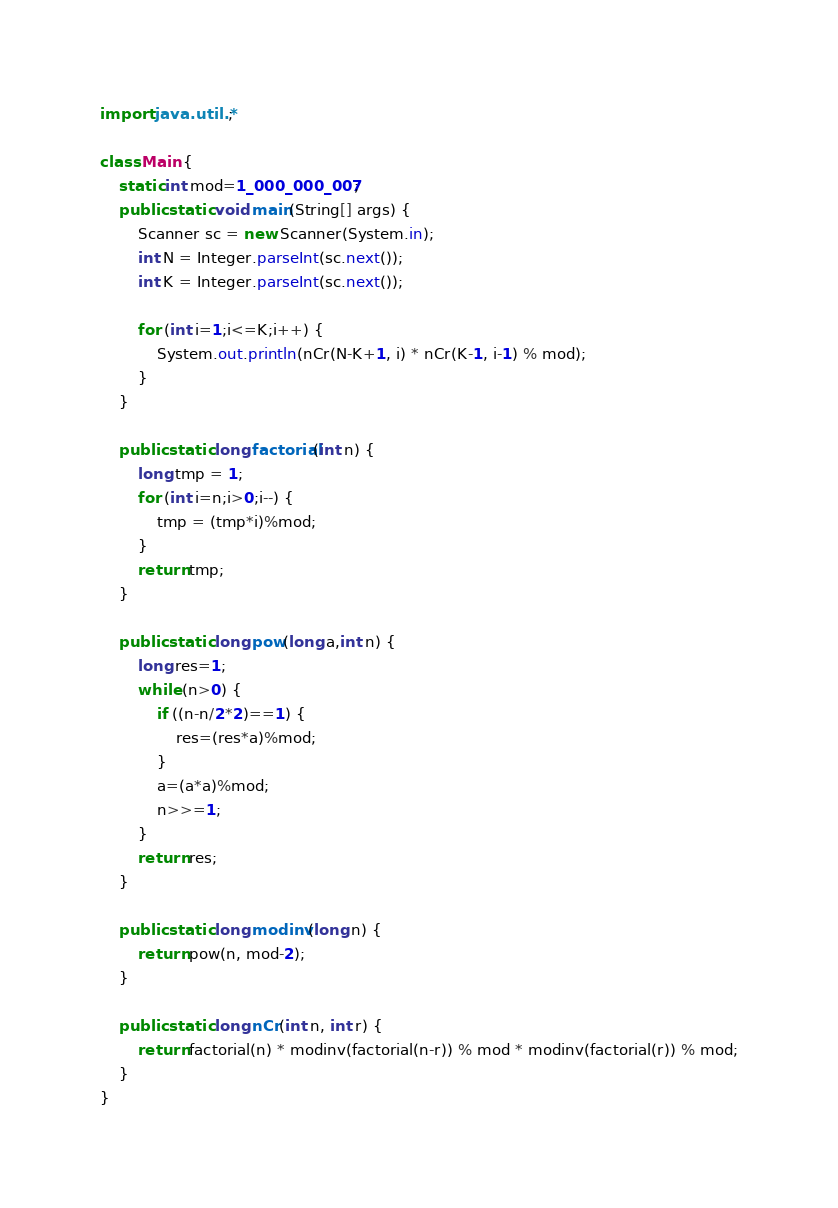<code> <loc_0><loc_0><loc_500><loc_500><_Java_>import java.util.*;

class Main {
	static int mod=1_000_000_007;
	public static void main(String[] args) {
		Scanner sc = new Scanner(System.in);
		int N = Integer.parseInt(sc.next());
		int K = Integer.parseInt(sc.next());

		for (int i=1;i<=K;i++) {
			System.out.println(nCr(N-K+1, i) * nCr(K-1, i-1) % mod);
		}
	}

	public static long factorial(int n) {
		long tmp = 1;
		for (int i=n;i>0;i--) {
			tmp = (tmp*i)%mod;
		}
		return tmp;
	}

	public static long pow(long a,int n) {
	    long res=1;
	    while (n>0) {
	        if ((n-n/2*2)==1) {
	            res=(res*a)%mod;
	        }
	        a=(a*a)%mod;
	        n>>=1;
	    }
	    return res;
	}

	public static long modinv(long n) {
		return pow(n, mod-2);
	}

	public static long nCr(int n, int r) {
		return factorial(n) * modinv(factorial(n-r)) % mod * modinv(factorial(r)) % mod;
	}
}</code> 